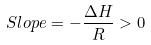Convert formula to latex. <formula><loc_0><loc_0><loc_500><loc_500>S l o p e = - \frac { \Delta H } { R } > 0</formula> 